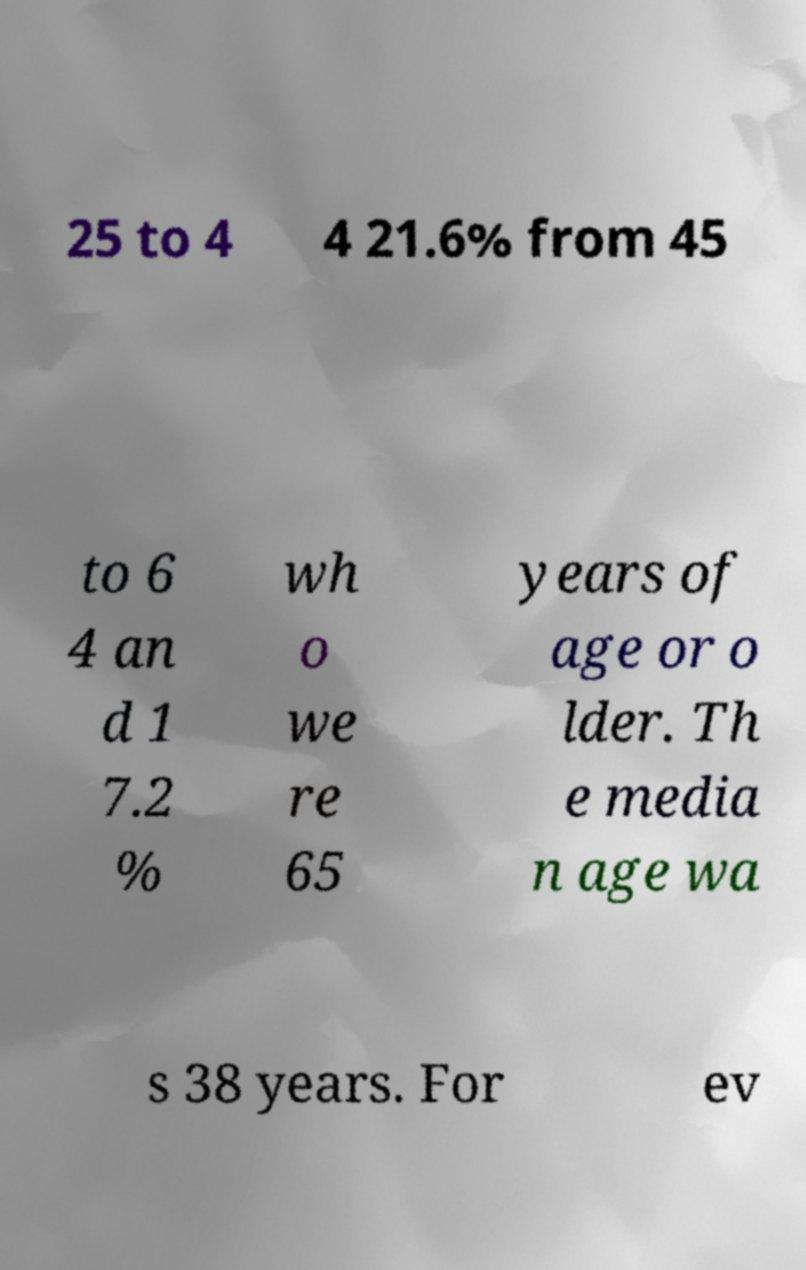Could you extract and type out the text from this image? 25 to 4 4 21.6% from 45 to 6 4 an d 1 7.2 % wh o we re 65 years of age or o lder. Th e media n age wa s 38 years. For ev 